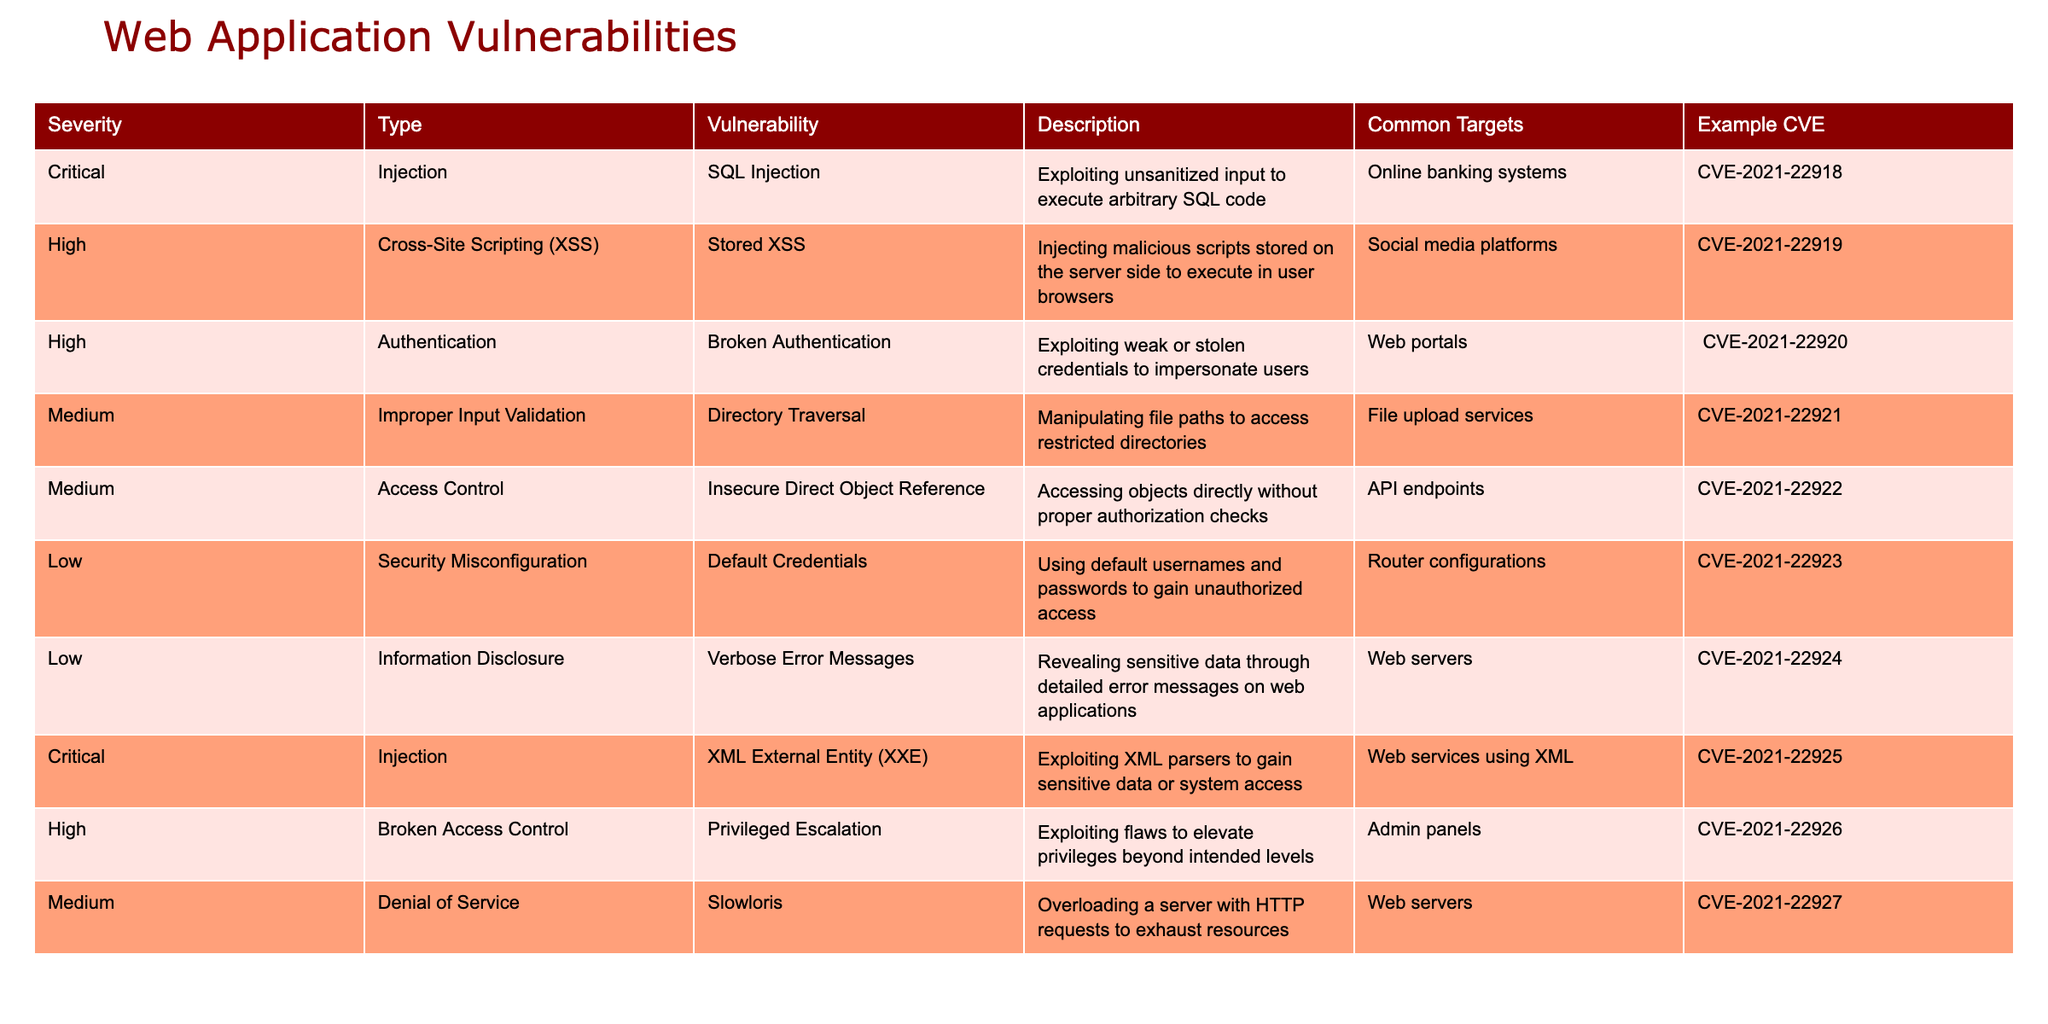What is the most severe type of vulnerability listed in the table? The table categorizes vulnerabilities by severity. By scanning the "Severity" column, it is clear that "Critical" is the highest severity level, and the vulnerabilities listed under this category are "SQL Injection" and "XML External Entity (XXE)."
Answer: Critical How many types of vulnerabilities are classified as "High"? To determine the number of "High" vulnerabilities, I will count the entries in the "Type" column that correspond to "High" in the "Severity" column. There are four "High" vulnerabilities listed: Stored XSS, Broken Authentication, Privileged Escalation.
Answer: 4 Is "Insecure Direct Object Reference" classified as a critical vulnerability? By checking the "Severity" column corresponding to "Insecure Direct Object Reference," it is listed under "Medium." Therefore, it is not classified as a critical vulnerability.
Answer: No What are the common targets for "Critical" vulnerabilities? The common targets for the "Critical" vulnerabilities can be found in the rows that have "Critical" in the "Severity" column. The common targets for these vulnerabilities (SQL Injection and XML External Entity (XXE)) include "Online banking systems" and "Web services using XML."
Answer: Online banking systems, Web services using XML Which type of vulnerability has the highest number of occurrences in the table? I will tally the different types of vulnerabilities by examining the "Type" column. Upon reviewing the table, "Injection" appears twice (for SQL Injection and XXE) making it the most frequent type.
Answer: Injection What is the average severity level of the vulnerabilities listed? The severity levels correspond to numeric values: Critical (3), High (2), Medium (1), and Low (0). Counting the occurrences: 2 Criticals, 4 Highs, 3 Mediums, and 2 Lows gives a total of (2*3 + 4*2 + 3*1 + 2*0) = 20. The total number of vulnerabilities is 11, so the average is 20/11 ≈ 1.82, which suggests between Medium and High.
Answer: Approximately Medium-High Are there any vulnerabilities related to Denial of Service attacks? By scanning the "Type" column for relevant terms, "Slowloris" is listed as a Denial of Service vulnerability. Therefore, yes, there is a vulnerability related to Denial of Service attacks in the table.
Answer: Yes What is one example of a vulnerability that targets API endpoints? Looking up the common targets and corresponding vulnerabilities, the vulnerability labeled "Insecure Direct Object Reference" specifically targets API endpoints.
Answer: Insecure Direct Object Reference 